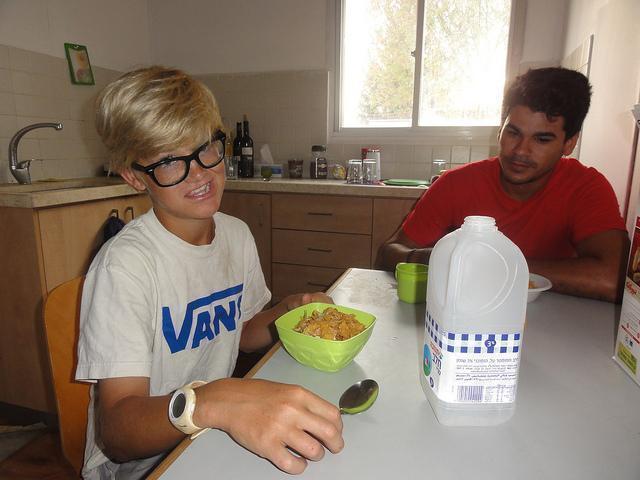What commodity has this young man exhausted?
Choose the correct response and explain in the format: 'Answer: answer
Rationale: rationale.'
Options: Oats, milk, wine, none. Answer: milk.
Rationale: The milk bottle is empty, indicating that all the milk has been consumed. What product does the young diner run out of here?
Make your selection from the four choices given to correctly answer the question.
Options: Vinegar, orange juice, milk, water. Milk. 